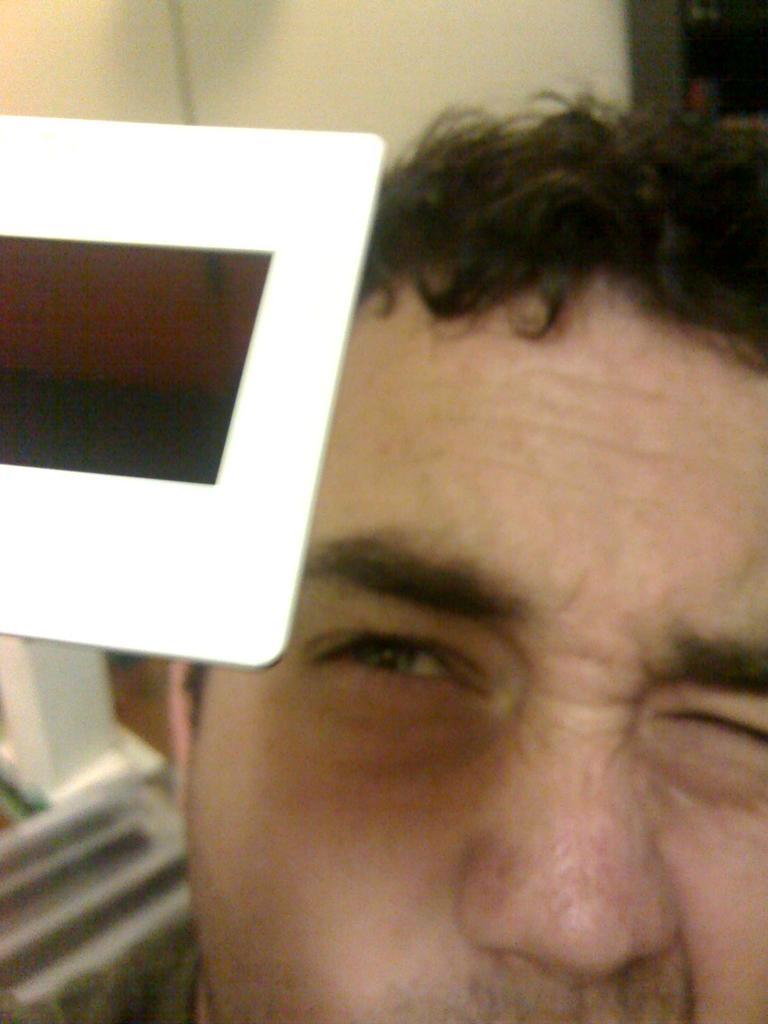Can you describe this image briefly? In this image, we can see a person face. There is an object on the left side of the image. 